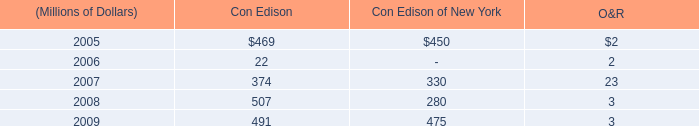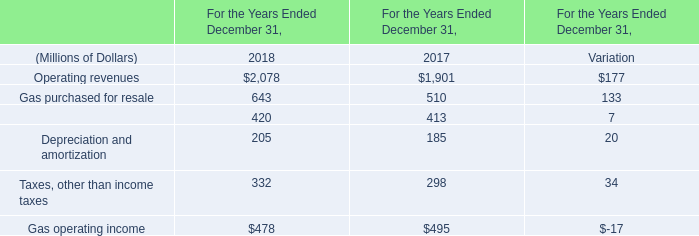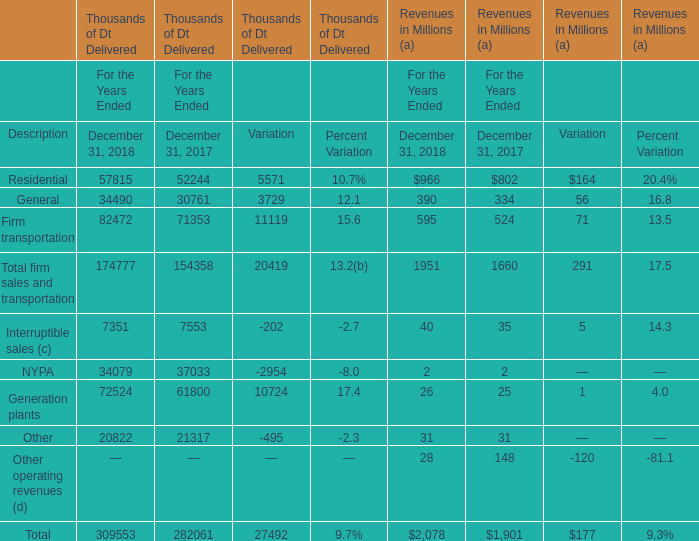In which years is Operating revenues greater than Gas purchased for resale? 
Answer: 2018. 